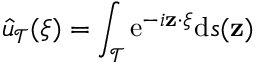Convert formula to latex. <formula><loc_0><loc_0><loc_500><loc_500>\hat { u } _ { \mathcal { T } } ( \xi ) = \int _ { \mathcal { T } } e ^ { - i z \cdot \xi } d s ( z )</formula> 